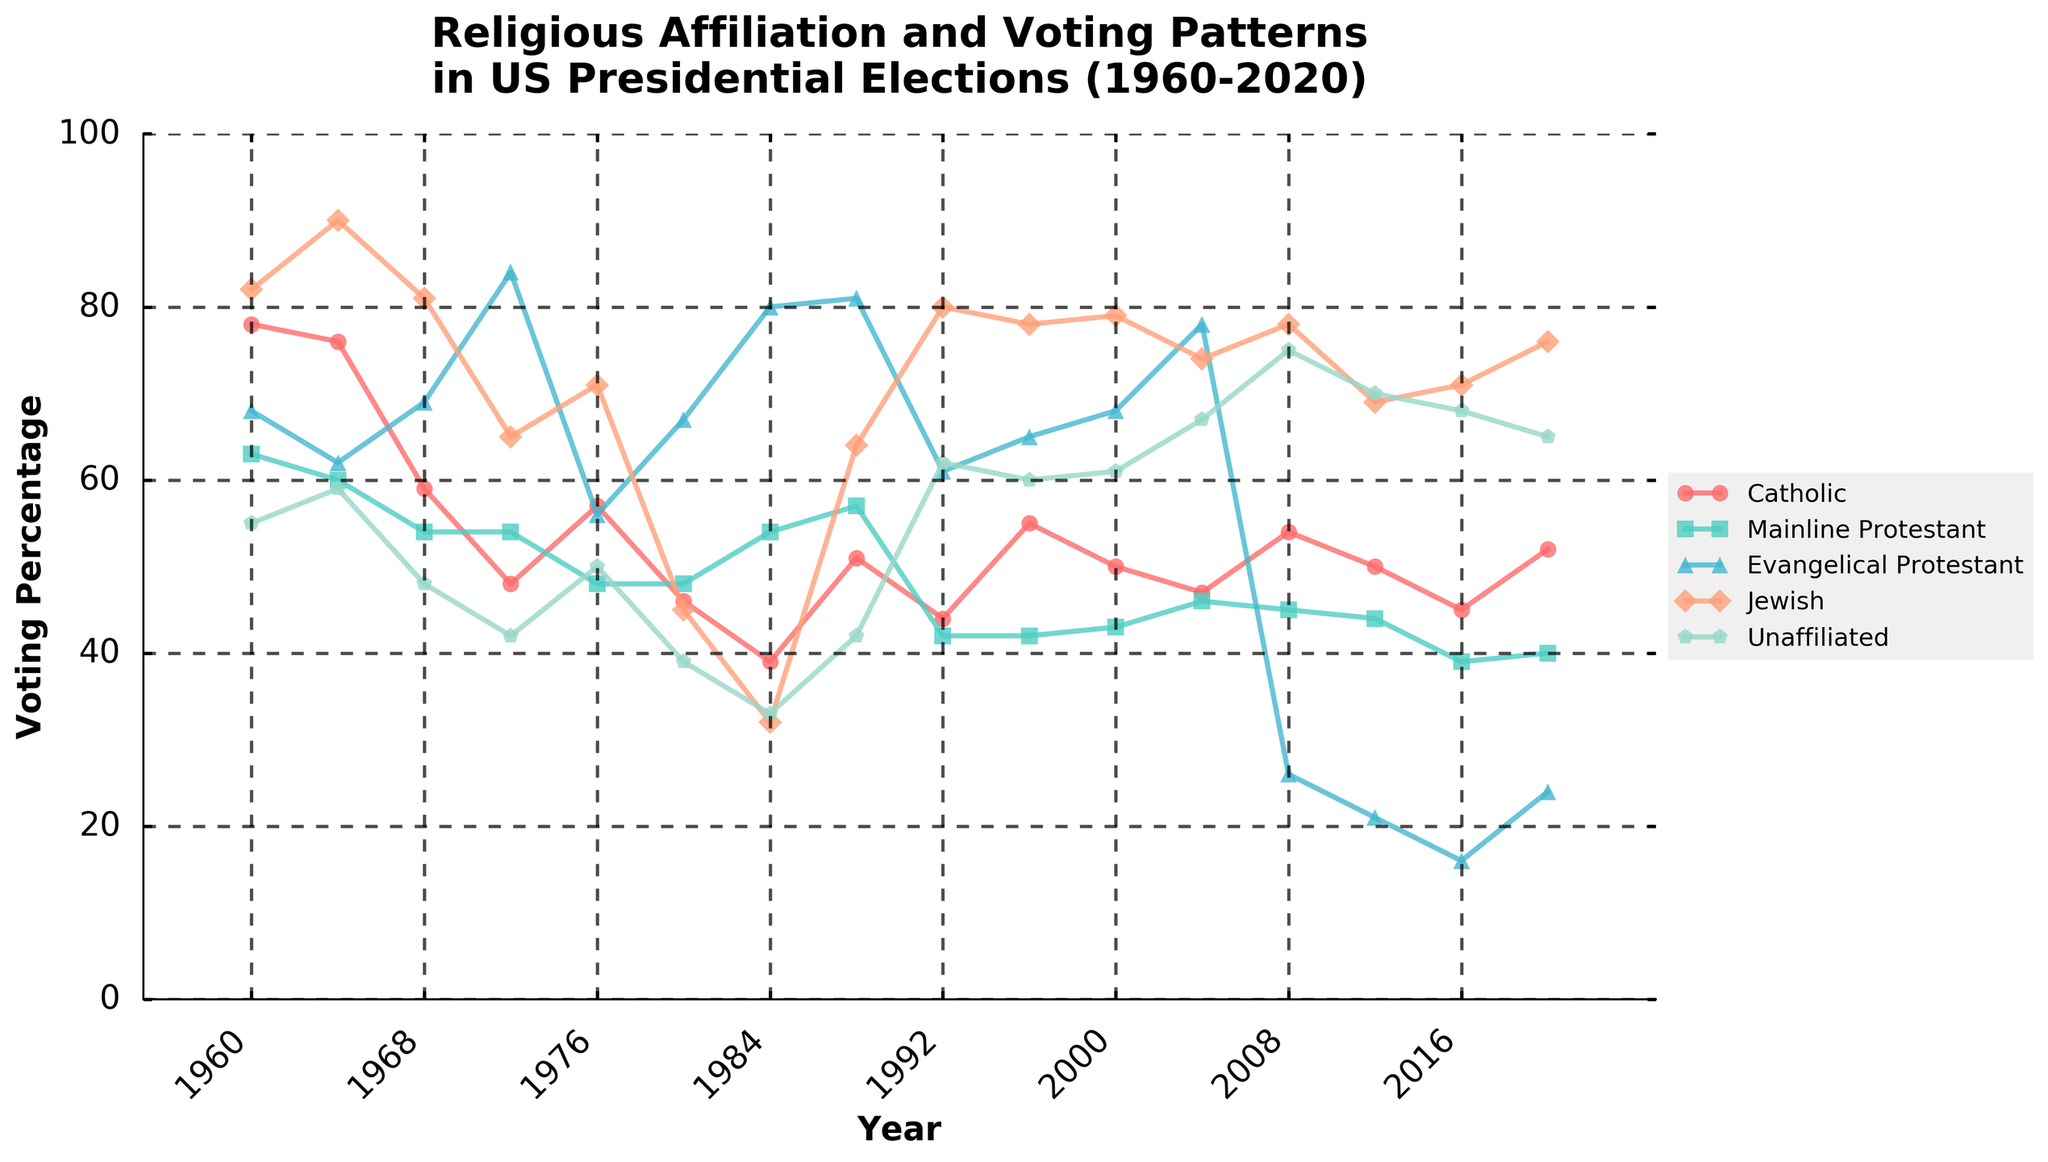When did Mainline Protestant voters show the highest voting percentage? To determine the peak voting percentage for Mainline Protestant voters, locate the highest point on the Mainline Protestant line on the graph. This occurs in 1988.
Answer: 1988 What's the difference in the voting percentage of Catholic voters between 1960 and 2020? Find the voting percentages of Catholic voters in 1960 and 2020 from the graph, which are 78 and 52, respectively. Then, subtract the 2020 value from the 1960 value: 78 - 52 = 26.
Answer: 26 Which group had the most significant decline in voting percentage from 1960 to 2020? By observing the trends for each group from 1960 to 2020, note that Evangelical Protestant voters dropped from 68% to 24%, a decline of 44%, which is the most significant.
Answer: Evangelical Protestant Between which consecutive years did Jewish voters experience their most substantial increase in voting percentage? Look for the largest vertical jump in the Jewish voters' line in the graph. The most significant increase is between 1960 and 1964, increasing from 82% to 90%.
Answer: 1960 to 1964 How did the voting percentage of Unaffiliated voters change from 2004 to 2008? Locate the data points for Unaffiliated voters in 2004 and 2008, which are 67% and 75%, respectively. Subtract the 2004 value from the 2008 value: 75 - 67 = 8.
Answer: Increased by 8 Which religious group had the most volatile voting pattern throughout the years, and how can you tell? Look at the graph lines for variability. The Mainline Protestant group fluctuates significantly, indicating the most volatility.
Answer: Mainline Protestant, based on fluctuating trend What was the average voting percentage for Jewish voters from 1960 to 2020? Sum all the Jewish percentages and divide by the count of election years: (82+90+81+65+71+45+32+64+80+78+79+74+78+69+71+76)/16 = 71.75.
Answer: 71.75 In which year did Evangelical Protestant voters show the largest voting percentage increase from the previous period? Compare the voting percentages of Evangelical Protestant voters for consecutive years and identify the largest increase, which occurred from 1968 (69%) to 1972 (84%), an increase of 15%.
Answer: 1972 How did the voting trend of Unaffiliated voters compare to that of Catholic voters from 2008 to 2020? Observe the general rise in the Unaffiliated line versus the decline and subsequent slight rise in the Catholic line from 2008 to 2020. Unaffiliated voters' percentage consistently increased, while Catholic voters' percentage showed a dip before partially recovering.
Answer: Unaffiliated voters increased, Catholic voters varied 